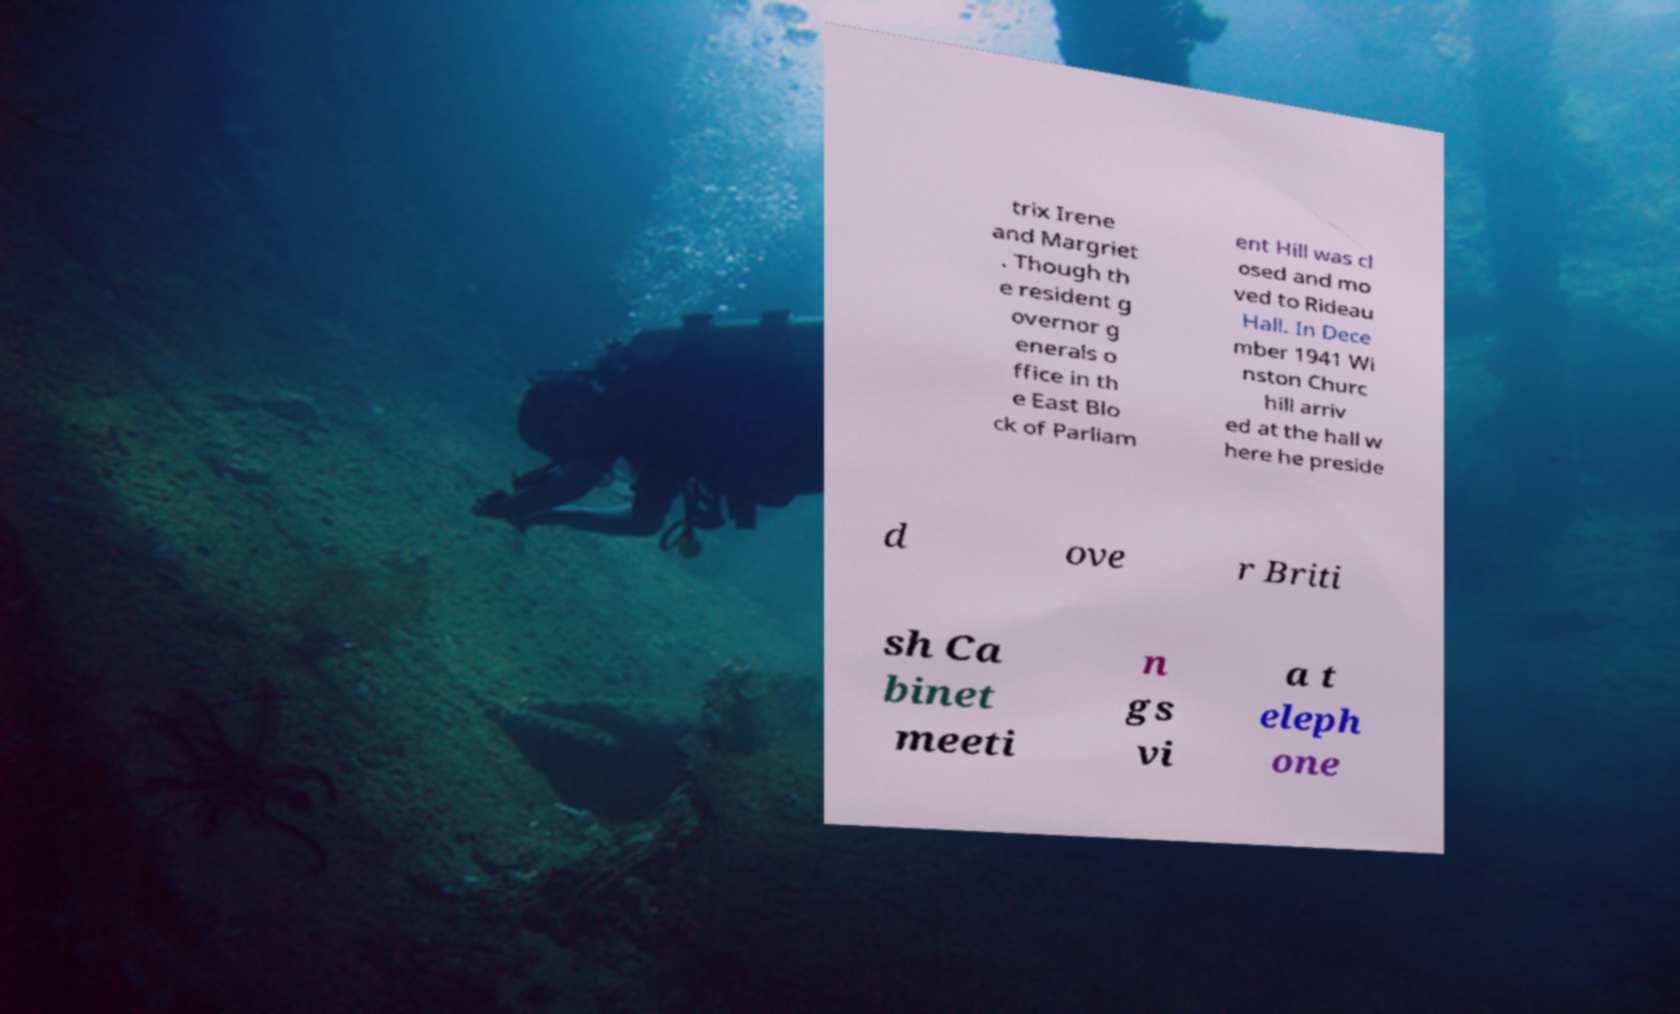There's text embedded in this image that I need extracted. Can you transcribe it verbatim? trix Irene and Margriet . Though th e resident g overnor g enerals o ffice in th e East Blo ck of Parliam ent Hill was cl osed and mo ved to Rideau Hall. In Dece mber 1941 Wi nston Churc hill arriv ed at the hall w here he preside d ove r Briti sh Ca binet meeti n gs vi a t eleph one 